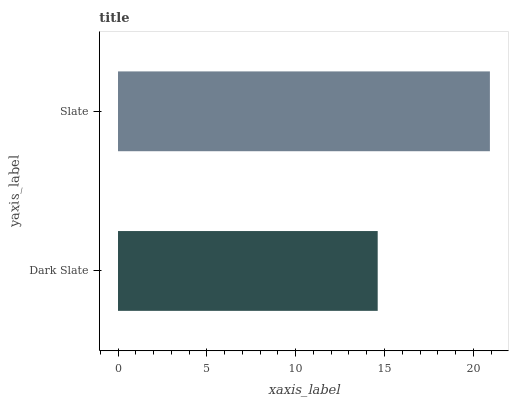Is Dark Slate the minimum?
Answer yes or no. Yes. Is Slate the maximum?
Answer yes or no. Yes. Is Slate the minimum?
Answer yes or no. No. Is Slate greater than Dark Slate?
Answer yes or no. Yes. Is Dark Slate less than Slate?
Answer yes or no. Yes. Is Dark Slate greater than Slate?
Answer yes or no. No. Is Slate less than Dark Slate?
Answer yes or no. No. Is Slate the high median?
Answer yes or no. Yes. Is Dark Slate the low median?
Answer yes or no. Yes. Is Dark Slate the high median?
Answer yes or no. No. Is Slate the low median?
Answer yes or no. No. 